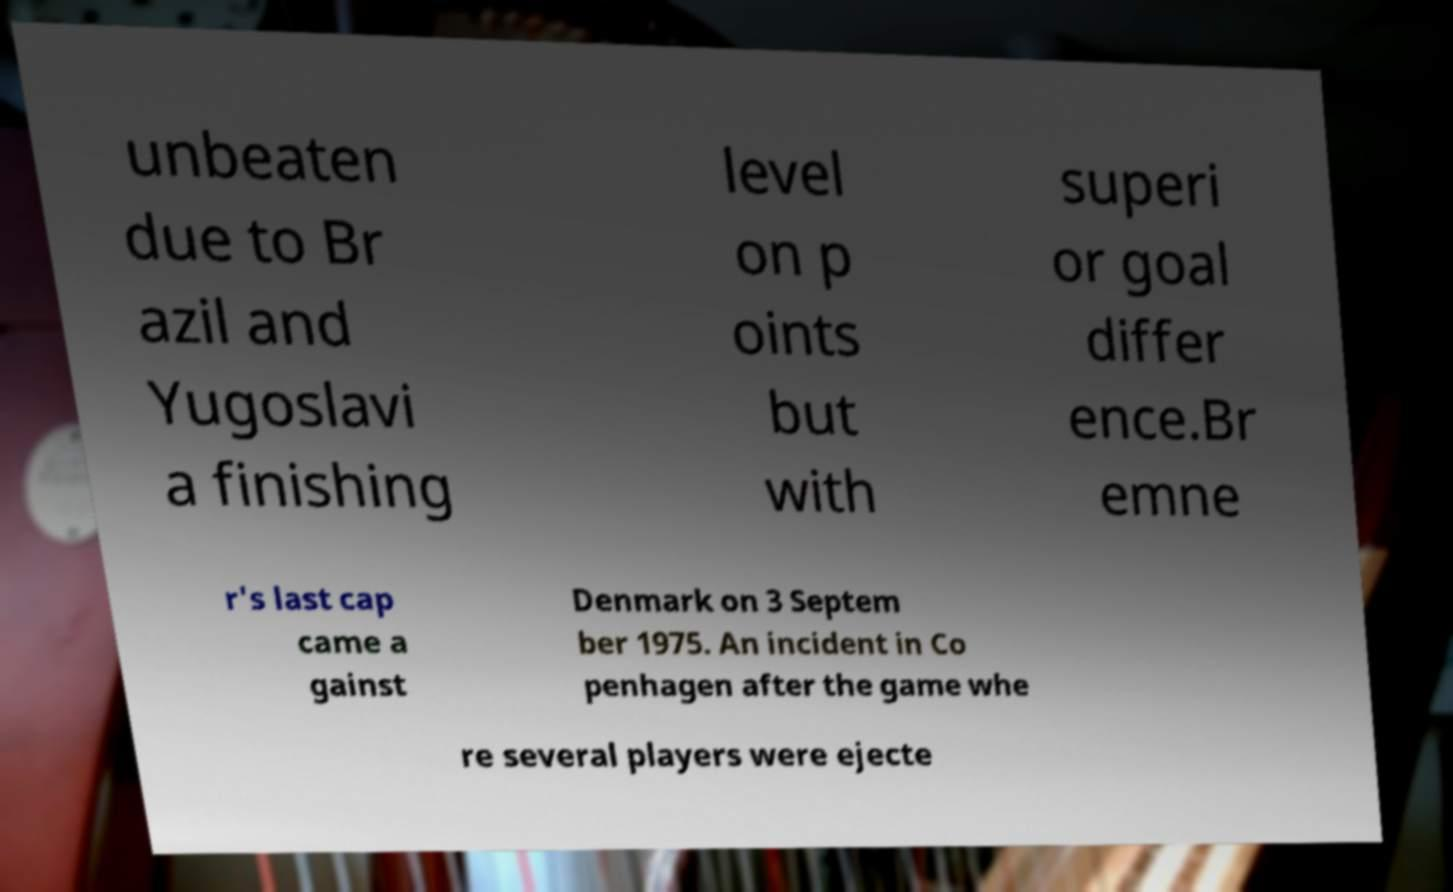Can you read and provide the text displayed in the image?This photo seems to have some interesting text. Can you extract and type it out for me? unbeaten due to Br azil and Yugoslavi a finishing level on p oints but with superi or goal differ ence.Br emne r's last cap came a gainst Denmark on 3 Septem ber 1975. An incident in Co penhagen after the game whe re several players were ejecte 